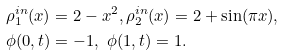<formula> <loc_0><loc_0><loc_500><loc_500>& \rho _ { 1 } ^ { i n } ( x ) = 2 - x ^ { 2 } , \rho _ { 2 } ^ { i n } ( x ) = 2 + \sin ( \pi x ) , \\ & \phi ( 0 , t ) = - 1 , \ \phi ( 1 , t ) = 1 .</formula> 